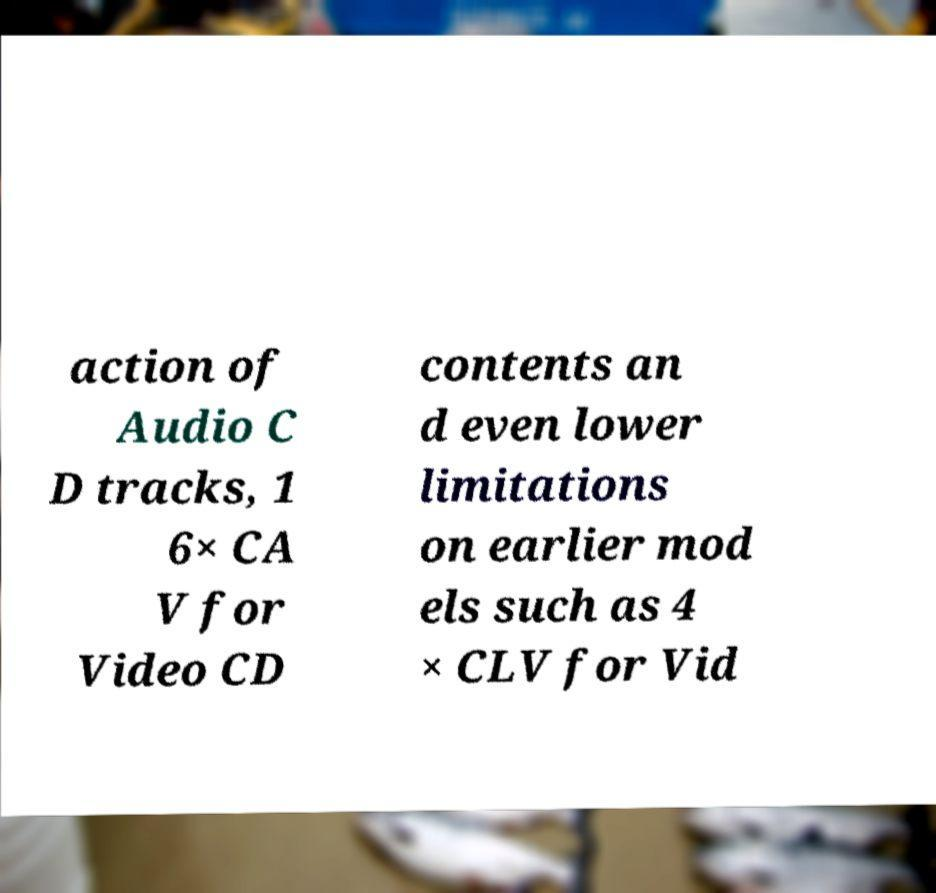Please read and relay the text visible in this image. What does it say? action of Audio C D tracks, 1 6× CA V for Video CD contents an d even lower limitations on earlier mod els such as 4 × CLV for Vid 